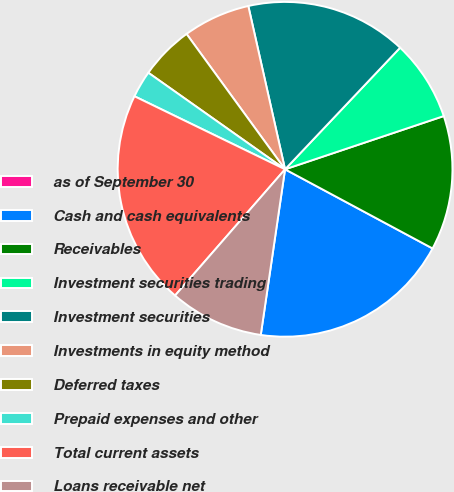Convert chart. <chart><loc_0><loc_0><loc_500><loc_500><pie_chart><fcel>as of September 30<fcel>Cash and cash equivalents<fcel>Receivables<fcel>Investment securities trading<fcel>Investment securities<fcel>Investments in equity method<fcel>Deferred taxes<fcel>Prepaid expenses and other<fcel>Total current assets<fcel>Loans receivable net<nl><fcel>0.0%<fcel>19.48%<fcel>12.99%<fcel>7.79%<fcel>15.58%<fcel>6.49%<fcel>5.2%<fcel>2.6%<fcel>20.78%<fcel>9.09%<nl></chart> 